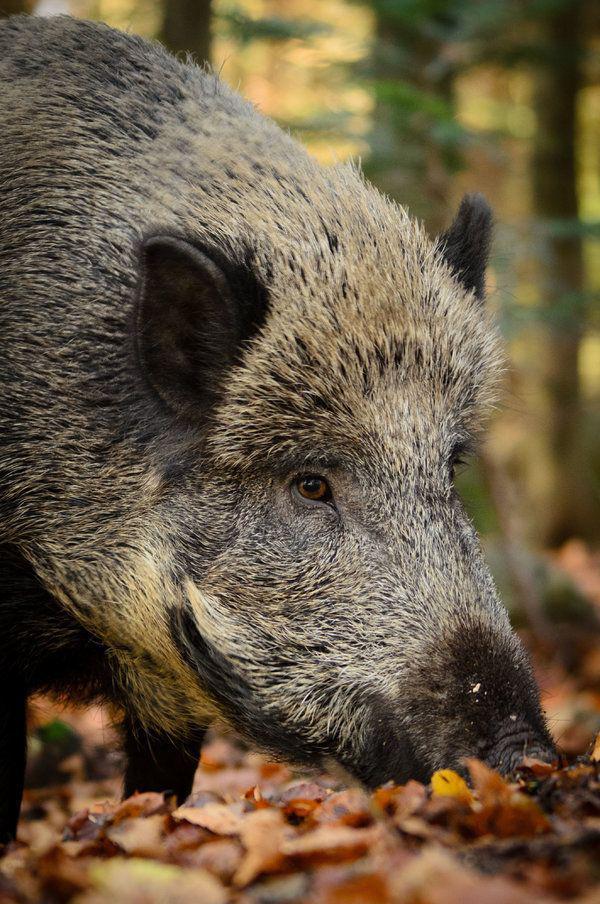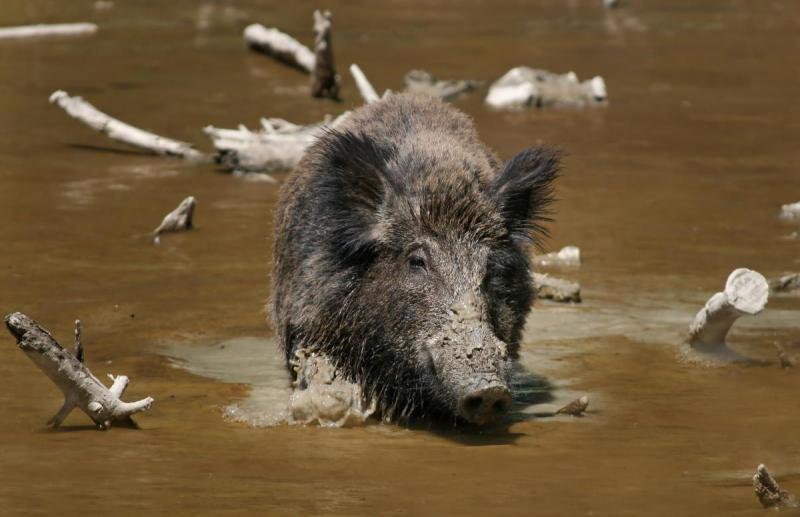The first image is the image on the left, the second image is the image on the right. Given the left and right images, does the statement "The pig in the image on the right is near a body of water." hold true? Answer yes or no. Yes. The first image is the image on the left, the second image is the image on the right. Evaluate the accuracy of this statement regarding the images: "At least one pig is in a walking pose heading leftward.". Is it true? Answer yes or no. No. 